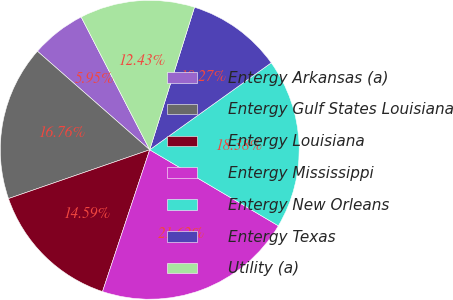<chart> <loc_0><loc_0><loc_500><loc_500><pie_chart><fcel>Entergy Arkansas (a)<fcel>Entergy Gulf States Louisiana<fcel>Entergy Louisiana<fcel>Entergy Mississippi<fcel>Entergy New Orleans<fcel>Entergy Texas<fcel>Utility (a)<nl><fcel>5.95%<fcel>16.76%<fcel>14.59%<fcel>21.62%<fcel>18.38%<fcel>10.27%<fcel>12.43%<nl></chart> 